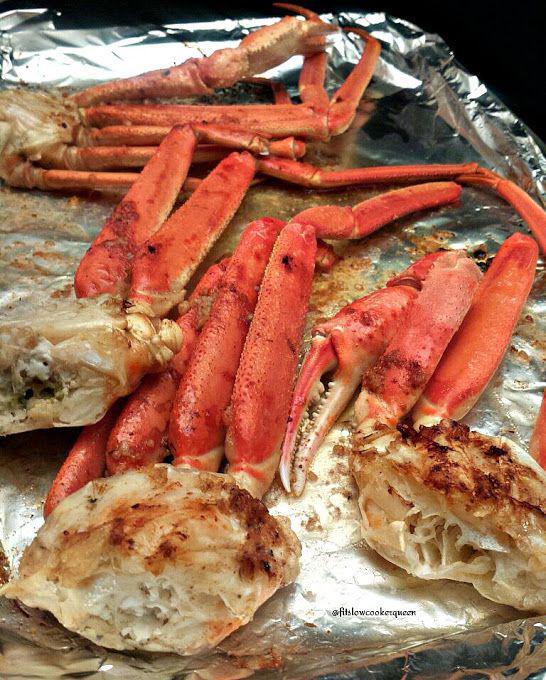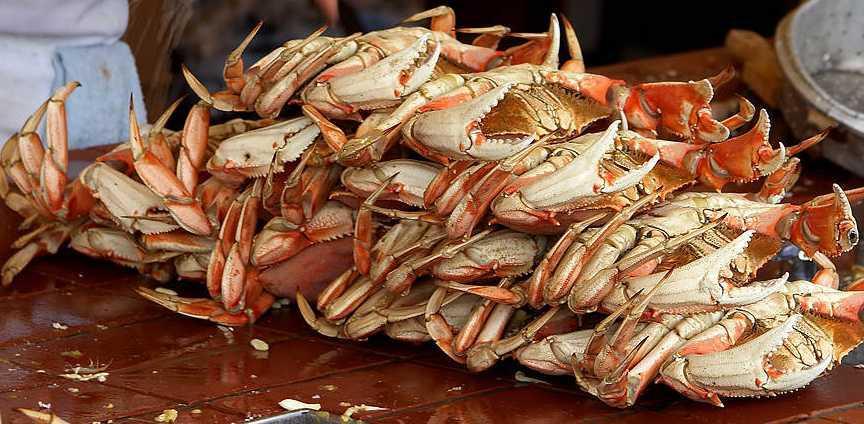The first image is the image on the left, the second image is the image on the right. Examine the images to the left and right. Is the description "One of the images has cooked crab pieces on foil." accurate? Answer yes or no. Yes. The first image is the image on the left, the second image is the image on the right. Given the left and right images, does the statement "Left and right images each show crab claws in some type of container used in a kitchen." hold true? Answer yes or no. No. 